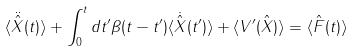Convert formula to latex. <formula><loc_0><loc_0><loc_500><loc_500>\langle \ddot { \hat { X } } ( t ) \rangle + \int _ { 0 } ^ { t } d t ^ { \prime } \beta ( t - t ^ { \prime } ) \langle \dot { \hat { X } } ( t ^ { \prime } ) \rangle + \langle V ^ { \prime } ( \hat { X } ) \rangle = \langle \hat { F } ( t ) \rangle</formula> 